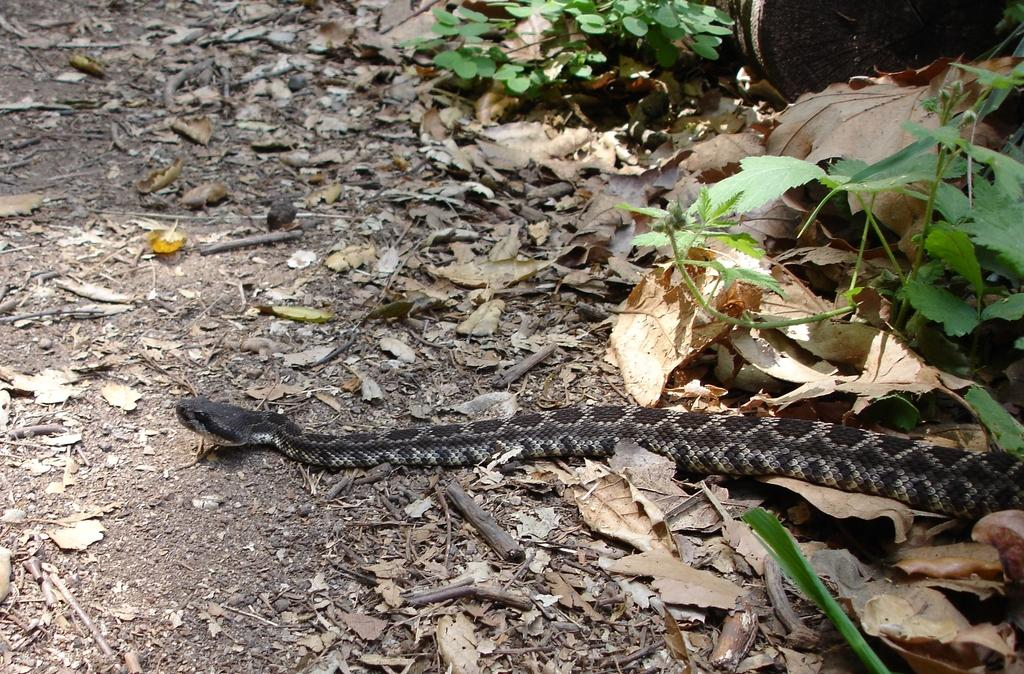What animal can be seen in the picture? There is a snake in the picture. What can be found in the right corner of the picture? There are plants and dried leaves in the right corner of the picture. What type of houses can be seen in the picture? There are no houses present in the picture; it features a snake and plants with dried leaves. What material is the straw made of in the picture? There is no straw present in the picture. 